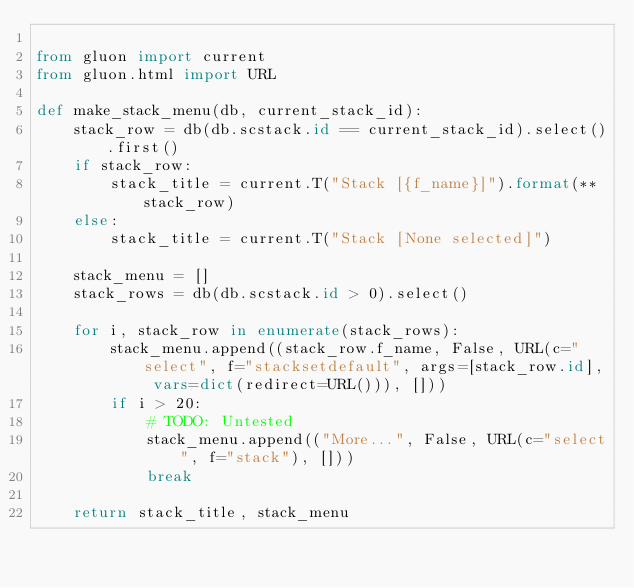Convert code to text. <code><loc_0><loc_0><loc_500><loc_500><_Python_>
from gluon import current
from gluon.html import URL

def make_stack_menu(db, current_stack_id):
    stack_row = db(db.scstack.id == current_stack_id).select().first()
    if stack_row:
        stack_title = current.T("Stack [{f_name}]").format(**stack_row)
    else:
        stack_title = current.T("Stack [None selected]")

    stack_menu = []
    stack_rows = db(db.scstack.id > 0).select()

    for i, stack_row in enumerate(stack_rows):
        stack_menu.append((stack_row.f_name, False, URL(c="select", f="stacksetdefault", args=[stack_row.id], vars=dict(redirect=URL())), []))
        if i > 20:
            # TODO: Untested
            stack_menu.append(("More...", False, URL(c="select", f="stack"), []))
            break

    return stack_title, stack_menu
</code> 